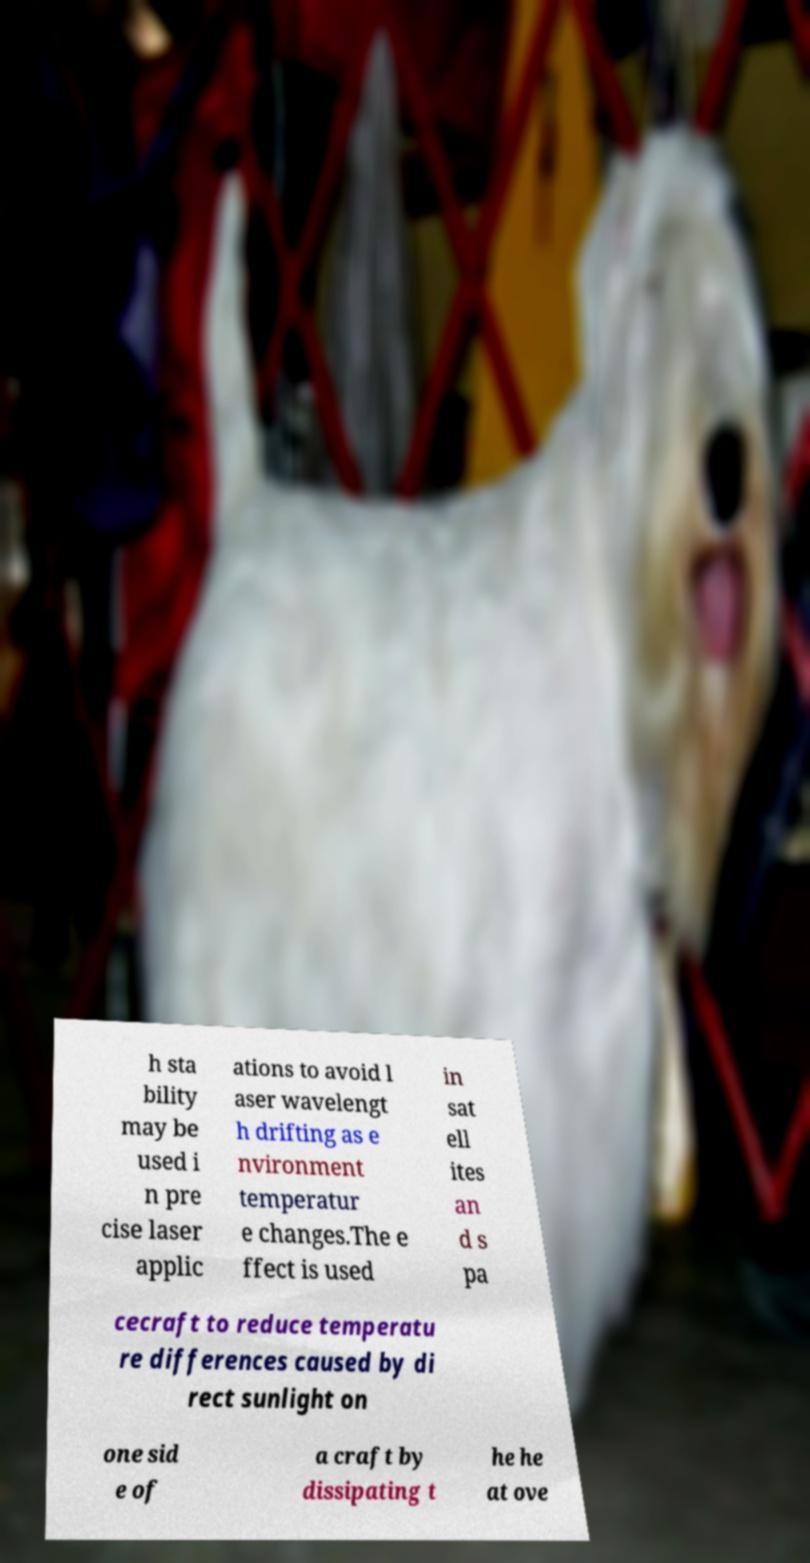Please read and relay the text visible in this image. What does it say? h sta bility may be used i n pre cise laser applic ations to avoid l aser wavelengt h drifting as e nvironment temperatur e changes.The e ffect is used in sat ell ites an d s pa cecraft to reduce temperatu re differences caused by di rect sunlight on one sid e of a craft by dissipating t he he at ove 